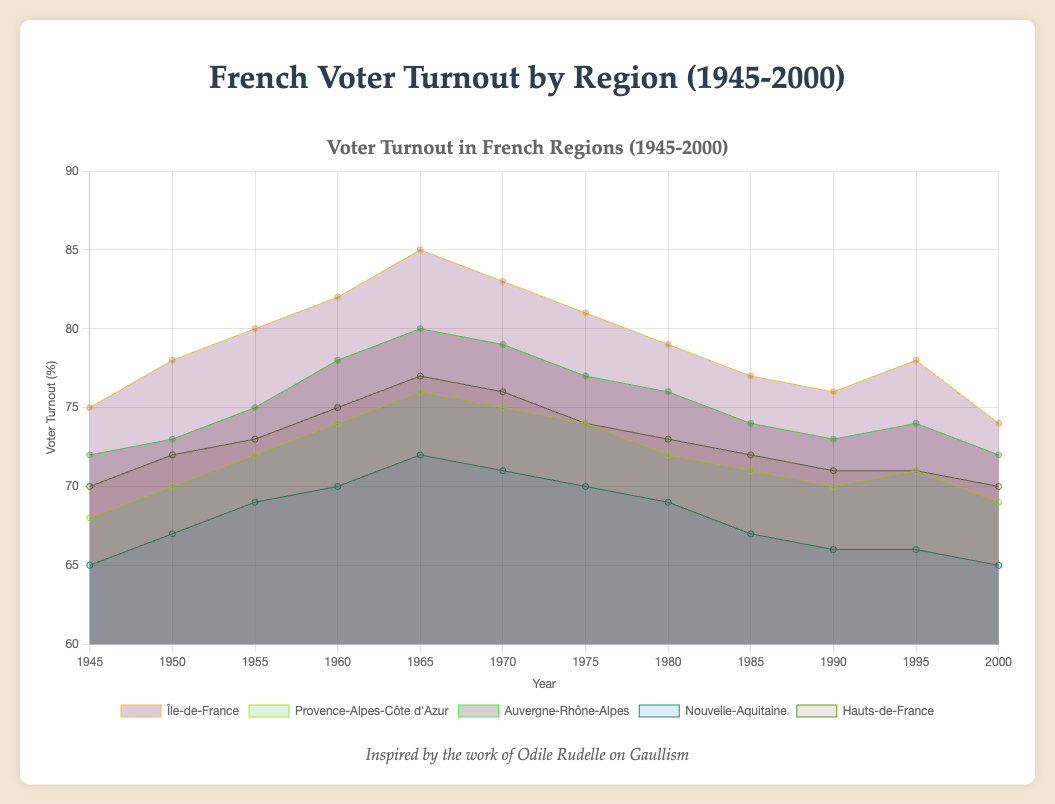Which region has the highest voter turnout in 1965? Look at the highest point on the graph for the year 1965 and find the corresponding region label.
Answer: Île-de-France How does the voter turnout in Île-de-France in 2000 compare to that in 1960? Find the 2000 and 1960 data points for Île-de-France and compare them. In 2000, the turnout is 74%, and in 1960, it's 82%. 74% is less than 82%, so turnout decreased.
Answer: Decreased Which region shows the most consistent voter turnout throughout 1945-2000? Look for the region where the area coverage remains relatively stable over the years without large fluctuations.
Answer: Hauts-de-France What is the average turnout for Nouvelle-Aquitaine across the years provided? Sum all the voter turnout values for Nouvelle-Aquitaine and divide by the number of years (12). (65+67+69+70+72+71+70+69+67+66+66+65) / 12 = 68.25
Answer: 68.25% Is there any region with a voter turnout above 80% consistently across all the years? Check each region's voter turnout data to see if all values are above 80%. Only Île-de-France reaches above 80% for a few years but not consistently.
Answer: No Between Île-de-France and Provence-Alpes-Côte d'Azur, which region had a higher turnout in 1980? Identify the voter turnout values for 1980 for both regions and compare. Île-de-France had 79% and Provence-Alpes-Côte d'Azur had 72%.
Answer: Île-de-France In which year did Auvergne-Rhône-Alpes have the highest voter turnout? Look for the peak value in the Auvergne-Rhône-Alpes line and check the corresponding year. The peak is 80% in 1965.
Answer: 1965 What trend can be observed for voter turnout in Hauts-de-France from 1945 to 2000? Observe the line for Hauts-de-France and note if it generally increases, decreases, or is stable. It starts at 70% in 1945 and returns to 70% in 2000, showing minor fluctuations but overall stability.
Answer: Stable What is the median voter turnout for Île-de-France across the given years? For Île-de-France, list out turnouts: 75, 78, 80, 82, 85, 83, 81, 79, 77, 76, 78, 74. Since there are 12 numbers, the median is the average of the 6th and 7th values when sorted, (80+81)/2 = 80.5.
Answer: 80.5% Comparing 1960 to 2000, how has voter turnout changed in Provence-Alpes-Côte d'Azur? Identify the values for 1960 (74%) and 2000 (69%) and determine the difference. Turnout decreased by 5%.
Answer: Decreased by 5% 